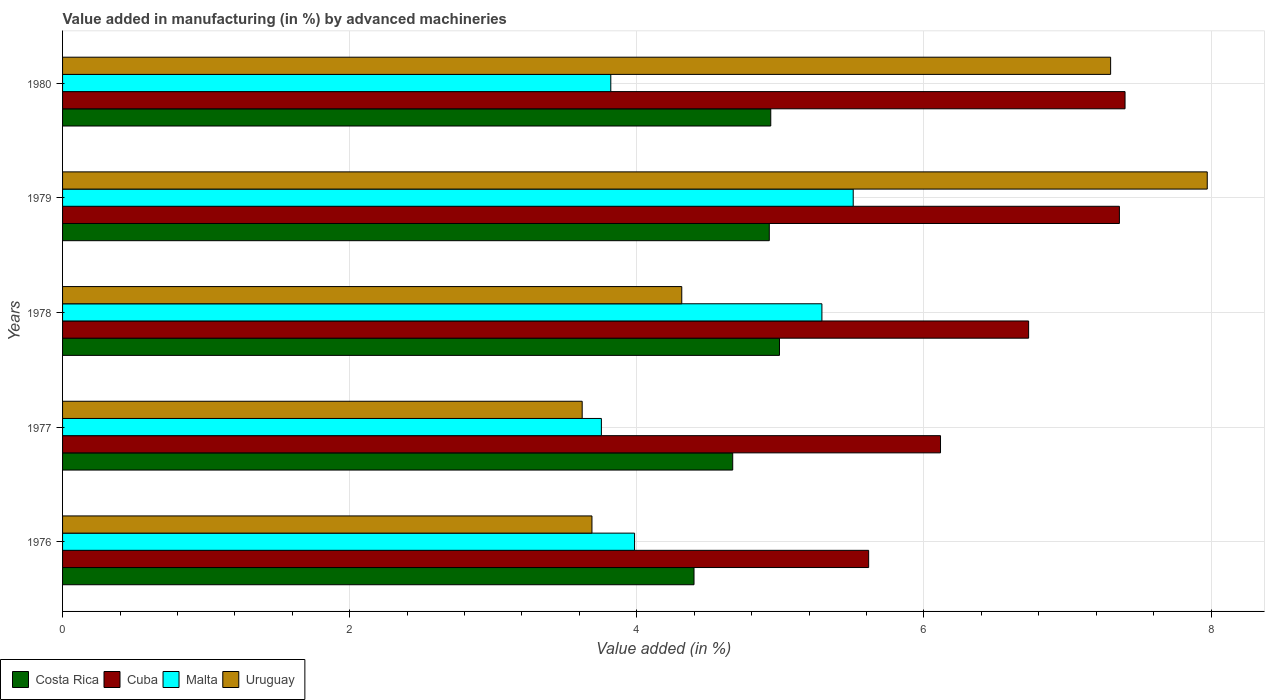How many groups of bars are there?
Make the answer very short. 5. Are the number of bars on each tick of the Y-axis equal?
Your answer should be compact. Yes. How many bars are there on the 5th tick from the top?
Your response must be concise. 4. What is the percentage of value added in manufacturing by advanced machineries in Costa Rica in 1979?
Your answer should be very brief. 4.92. Across all years, what is the maximum percentage of value added in manufacturing by advanced machineries in Malta?
Offer a very short reply. 5.51. Across all years, what is the minimum percentage of value added in manufacturing by advanced machineries in Malta?
Keep it short and to the point. 3.75. In which year was the percentage of value added in manufacturing by advanced machineries in Costa Rica maximum?
Keep it short and to the point. 1978. In which year was the percentage of value added in manufacturing by advanced machineries in Costa Rica minimum?
Keep it short and to the point. 1976. What is the total percentage of value added in manufacturing by advanced machineries in Cuba in the graph?
Provide a succinct answer. 33.22. What is the difference between the percentage of value added in manufacturing by advanced machineries in Costa Rica in 1976 and that in 1980?
Your response must be concise. -0.53. What is the difference between the percentage of value added in manufacturing by advanced machineries in Cuba in 1980 and the percentage of value added in manufacturing by advanced machineries in Costa Rica in 1977?
Your response must be concise. 2.73. What is the average percentage of value added in manufacturing by advanced machineries in Costa Rica per year?
Make the answer very short. 4.78. In the year 1978, what is the difference between the percentage of value added in manufacturing by advanced machineries in Costa Rica and percentage of value added in manufacturing by advanced machineries in Uruguay?
Give a very brief answer. 0.68. In how many years, is the percentage of value added in manufacturing by advanced machineries in Costa Rica greater than 5.6 %?
Offer a very short reply. 0. What is the ratio of the percentage of value added in manufacturing by advanced machineries in Costa Rica in 1977 to that in 1979?
Make the answer very short. 0.95. What is the difference between the highest and the second highest percentage of value added in manufacturing by advanced machineries in Malta?
Your answer should be compact. 0.22. What is the difference between the highest and the lowest percentage of value added in manufacturing by advanced machineries in Uruguay?
Offer a terse response. 4.35. In how many years, is the percentage of value added in manufacturing by advanced machineries in Cuba greater than the average percentage of value added in manufacturing by advanced machineries in Cuba taken over all years?
Offer a very short reply. 3. Is the sum of the percentage of value added in manufacturing by advanced machineries in Cuba in 1978 and 1979 greater than the maximum percentage of value added in manufacturing by advanced machineries in Malta across all years?
Give a very brief answer. Yes. What does the 2nd bar from the top in 1976 represents?
Give a very brief answer. Malta. What does the 3rd bar from the bottom in 1980 represents?
Ensure brevity in your answer.  Malta. Is it the case that in every year, the sum of the percentage of value added in manufacturing by advanced machineries in Costa Rica and percentage of value added in manufacturing by advanced machineries in Uruguay is greater than the percentage of value added in manufacturing by advanced machineries in Cuba?
Keep it short and to the point. Yes. How many years are there in the graph?
Keep it short and to the point. 5. What is the difference between two consecutive major ticks on the X-axis?
Ensure brevity in your answer.  2. Are the values on the major ticks of X-axis written in scientific E-notation?
Your response must be concise. No. Does the graph contain any zero values?
Your answer should be very brief. No. Does the graph contain grids?
Provide a succinct answer. Yes. How many legend labels are there?
Offer a terse response. 4. What is the title of the graph?
Give a very brief answer. Value added in manufacturing (in %) by advanced machineries. Does "United Arab Emirates" appear as one of the legend labels in the graph?
Make the answer very short. No. What is the label or title of the X-axis?
Keep it short and to the point. Value added (in %). What is the Value added (in %) of Costa Rica in 1976?
Keep it short and to the point. 4.4. What is the Value added (in %) in Cuba in 1976?
Your answer should be compact. 5.61. What is the Value added (in %) of Malta in 1976?
Offer a terse response. 3.98. What is the Value added (in %) of Uruguay in 1976?
Make the answer very short. 3.69. What is the Value added (in %) in Costa Rica in 1977?
Your answer should be very brief. 4.67. What is the Value added (in %) in Cuba in 1977?
Your answer should be very brief. 6.12. What is the Value added (in %) in Malta in 1977?
Provide a succinct answer. 3.75. What is the Value added (in %) of Uruguay in 1977?
Offer a terse response. 3.62. What is the Value added (in %) in Costa Rica in 1978?
Provide a short and direct response. 4.99. What is the Value added (in %) in Cuba in 1978?
Offer a terse response. 6.73. What is the Value added (in %) in Malta in 1978?
Offer a terse response. 5.29. What is the Value added (in %) of Uruguay in 1978?
Your answer should be compact. 4.31. What is the Value added (in %) in Costa Rica in 1979?
Your response must be concise. 4.92. What is the Value added (in %) of Cuba in 1979?
Keep it short and to the point. 7.36. What is the Value added (in %) of Malta in 1979?
Offer a terse response. 5.51. What is the Value added (in %) in Uruguay in 1979?
Offer a terse response. 7.97. What is the Value added (in %) of Costa Rica in 1980?
Provide a short and direct response. 4.93. What is the Value added (in %) of Cuba in 1980?
Ensure brevity in your answer.  7.4. What is the Value added (in %) of Malta in 1980?
Provide a short and direct response. 3.82. What is the Value added (in %) of Uruguay in 1980?
Provide a succinct answer. 7.3. Across all years, what is the maximum Value added (in %) of Costa Rica?
Make the answer very short. 4.99. Across all years, what is the maximum Value added (in %) of Cuba?
Keep it short and to the point. 7.4. Across all years, what is the maximum Value added (in %) in Malta?
Provide a succinct answer. 5.51. Across all years, what is the maximum Value added (in %) in Uruguay?
Your answer should be compact. 7.97. Across all years, what is the minimum Value added (in %) in Costa Rica?
Give a very brief answer. 4.4. Across all years, what is the minimum Value added (in %) in Cuba?
Offer a very short reply. 5.61. Across all years, what is the minimum Value added (in %) in Malta?
Keep it short and to the point. 3.75. Across all years, what is the minimum Value added (in %) in Uruguay?
Give a very brief answer. 3.62. What is the total Value added (in %) in Costa Rica in the graph?
Offer a very short reply. 23.91. What is the total Value added (in %) in Cuba in the graph?
Offer a very short reply. 33.22. What is the total Value added (in %) in Malta in the graph?
Provide a succinct answer. 22.35. What is the total Value added (in %) of Uruguay in the graph?
Keep it short and to the point. 26.89. What is the difference between the Value added (in %) of Costa Rica in 1976 and that in 1977?
Provide a succinct answer. -0.27. What is the difference between the Value added (in %) of Cuba in 1976 and that in 1977?
Keep it short and to the point. -0.5. What is the difference between the Value added (in %) in Malta in 1976 and that in 1977?
Offer a terse response. 0.23. What is the difference between the Value added (in %) of Uruguay in 1976 and that in 1977?
Offer a terse response. 0.07. What is the difference between the Value added (in %) in Costa Rica in 1976 and that in 1978?
Provide a succinct answer. -0.6. What is the difference between the Value added (in %) of Cuba in 1976 and that in 1978?
Give a very brief answer. -1.11. What is the difference between the Value added (in %) of Malta in 1976 and that in 1978?
Give a very brief answer. -1.3. What is the difference between the Value added (in %) of Uruguay in 1976 and that in 1978?
Ensure brevity in your answer.  -0.63. What is the difference between the Value added (in %) of Costa Rica in 1976 and that in 1979?
Your response must be concise. -0.52. What is the difference between the Value added (in %) in Cuba in 1976 and that in 1979?
Offer a terse response. -1.75. What is the difference between the Value added (in %) in Malta in 1976 and that in 1979?
Give a very brief answer. -1.52. What is the difference between the Value added (in %) of Uruguay in 1976 and that in 1979?
Provide a short and direct response. -4.29. What is the difference between the Value added (in %) of Costa Rica in 1976 and that in 1980?
Make the answer very short. -0.53. What is the difference between the Value added (in %) of Cuba in 1976 and that in 1980?
Offer a terse response. -1.79. What is the difference between the Value added (in %) in Malta in 1976 and that in 1980?
Your answer should be very brief. 0.17. What is the difference between the Value added (in %) of Uruguay in 1976 and that in 1980?
Offer a terse response. -3.61. What is the difference between the Value added (in %) in Costa Rica in 1977 and that in 1978?
Make the answer very short. -0.33. What is the difference between the Value added (in %) in Cuba in 1977 and that in 1978?
Provide a succinct answer. -0.61. What is the difference between the Value added (in %) in Malta in 1977 and that in 1978?
Give a very brief answer. -1.54. What is the difference between the Value added (in %) of Uruguay in 1977 and that in 1978?
Provide a succinct answer. -0.69. What is the difference between the Value added (in %) in Costa Rica in 1977 and that in 1979?
Provide a short and direct response. -0.25. What is the difference between the Value added (in %) of Cuba in 1977 and that in 1979?
Offer a terse response. -1.25. What is the difference between the Value added (in %) of Malta in 1977 and that in 1979?
Keep it short and to the point. -1.75. What is the difference between the Value added (in %) of Uruguay in 1977 and that in 1979?
Ensure brevity in your answer.  -4.35. What is the difference between the Value added (in %) in Costa Rica in 1977 and that in 1980?
Offer a very short reply. -0.27. What is the difference between the Value added (in %) of Cuba in 1977 and that in 1980?
Keep it short and to the point. -1.29. What is the difference between the Value added (in %) of Malta in 1977 and that in 1980?
Your answer should be very brief. -0.07. What is the difference between the Value added (in %) of Uruguay in 1977 and that in 1980?
Offer a very short reply. -3.68. What is the difference between the Value added (in %) of Costa Rica in 1978 and that in 1979?
Your response must be concise. 0.07. What is the difference between the Value added (in %) in Cuba in 1978 and that in 1979?
Give a very brief answer. -0.63. What is the difference between the Value added (in %) in Malta in 1978 and that in 1979?
Ensure brevity in your answer.  -0.22. What is the difference between the Value added (in %) in Uruguay in 1978 and that in 1979?
Keep it short and to the point. -3.66. What is the difference between the Value added (in %) in Costa Rica in 1978 and that in 1980?
Your response must be concise. 0.06. What is the difference between the Value added (in %) in Cuba in 1978 and that in 1980?
Your answer should be compact. -0.67. What is the difference between the Value added (in %) of Malta in 1978 and that in 1980?
Make the answer very short. 1.47. What is the difference between the Value added (in %) in Uruguay in 1978 and that in 1980?
Give a very brief answer. -2.99. What is the difference between the Value added (in %) in Costa Rica in 1979 and that in 1980?
Your answer should be very brief. -0.01. What is the difference between the Value added (in %) of Cuba in 1979 and that in 1980?
Make the answer very short. -0.04. What is the difference between the Value added (in %) of Malta in 1979 and that in 1980?
Provide a short and direct response. 1.69. What is the difference between the Value added (in %) of Uruguay in 1979 and that in 1980?
Your answer should be very brief. 0.67. What is the difference between the Value added (in %) of Costa Rica in 1976 and the Value added (in %) of Cuba in 1977?
Your answer should be compact. -1.72. What is the difference between the Value added (in %) in Costa Rica in 1976 and the Value added (in %) in Malta in 1977?
Offer a terse response. 0.65. What is the difference between the Value added (in %) of Costa Rica in 1976 and the Value added (in %) of Uruguay in 1977?
Your answer should be compact. 0.78. What is the difference between the Value added (in %) in Cuba in 1976 and the Value added (in %) in Malta in 1977?
Your answer should be compact. 1.86. What is the difference between the Value added (in %) of Cuba in 1976 and the Value added (in %) of Uruguay in 1977?
Keep it short and to the point. 2. What is the difference between the Value added (in %) in Malta in 1976 and the Value added (in %) in Uruguay in 1977?
Provide a succinct answer. 0.36. What is the difference between the Value added (in %) of Costa Rica in 1976 and the Value added (in %) of Cuba in 1978?
Keep it short and to the point. -2.33. What is the difference between the Value added (in %) of Costa Rica in 1976 and the Value added (in %) of Malta in 1978?
Give a very brief answer. -0.89. What is the difference between the Value added (in %) of Costa Rica in 1976 and the Value added (in %) of Uruguay in 1978?
Provide a succinct answer. 0.09. What is the difference between the Value added (in %) of Cuba in 1976 and the Value added (in %) of Malta in 1978?
Provide a succinct answer. 0.33. What is the difference between the Value added (in %) in Cuba in 1976 and the Value added (in %) in Uruguay in 1978?
Ensure brevity in your answer.  1.3. What is the difference between the Value added (in %) of Malta in 1976 and the Value added (in %) of Uruguay in 1978?
Provide a succinct answer. -0.33. What is the difference between the Value added (in %) of Costa Rica in 1976 and the Value added (in %) of Cuba in 1979?
Make the answer very short. -2.96. What is the difference between the Value added (in %) in Costa Rica in 1976 and the Value added (in %) in Malta in 1979?
Your response must be concise. -1.11. What is the difference between the Value added (in %) of Costa Rica in 1976 and the Value added (in %) of Uruguay in 1979?
Your response must be concise. -3.57. What is the difference between the Value added (in %) of Cuba in 1976 and the Value added (in %) of Malta in 1979?
Offer a terse response. 0.11. What is the difference between the Value added (in %) in Cuba in 1976 and the Value added (in %) in Uruguay in 1979?
Provide a short and direct response. -2.36. What is the difference between the Value added (in %) of Malta in 1976 and the Value added (in %) of Uruguay in 1979?
Provide a succinct answer. -3.99. What is the difference between the Value added (in %) of Costa Rica in 1976 and the Value added (in %) of Cuba in 1980?
Your answer should be compact. -3. What is the difference between the Value added (in %) of Costa Rica in 1976 and the Value added (in %) of Malta in 1980?
Your answer should be compact. 0.58. What is the difference between the Value added (in %) of Costa Rica in 1976 and the Value added (in %) of Uruguay in 1980?
Give a very brief answer. -2.9. What is the difference between the Value added (in %) of Cuba in 1976 and the Value added (in %) of Malta in 1980?
Your answer should be very brief. 1.8. What is the difference between the Value added (in %) of Cuba in 1976 and the Value added (in %) of Uruguay in 1980?
Offer a terse response. -1.69. What is the difference between the Value added (in %) in Malta in 1976 and the Value added (in %) in Uruguay in 1980?
Your response must be concise. -3.32. What is the difference between the Value added (in %) of Costa Rica in 1977 and the Value added (in %) of Cuba in 1978?
Provide a short and direct response. -2.06. What is the difference between the Value added (in %) in Costa Rica in 1977 and the Value added (in %) in Malta in 1978?
Your response must be concise. -0.62. What is the difference between the Value added (in %) in Costa Rica in 1977 and the Value added (in %) in Uruguay in 1978?
Provide a short and direct response. 0.35. What is the difference between the Value added (in %) of Cuba in 1977 and the Value added (in %) of Malta in 1978?
Make the answer very short. 0.83. What is the difference between the Value added (in %) in Cuba in 1977 and the Value added (in %) in Uruguay in 1978?
Your answer should be compact. 1.8. What is the difference between the Value added (in %) of Malta in 1977 and the Value added (in %) of Uruguay in 1978?
Your response must be concise. -0.56. What is the difference between the Value added (in %) in Costa Rica in 1977 and the Value added (in %) in Cuba in 1979?
Give a very brief answer. -2.69. What is the difference between the Value added (in %) in Costa Rica in 1977 and the Value added (in %) in Malta in 1979?
Your response must be concise. -0.84. What is the difference between the Value added (in %) in Costa Rica in 1977 and the Value added (in %) in Uruguay in 1979?
Provide a short and direct response. -3.31. What is the difference between the Value added (in %) in Cuba in 1977 and the Value added (in %) in Malta in 1979?
Give a very brief answer. 0.61. What is the difference between the Value added (in %) of Cuba in 1977 and the Value added (in %) of Uruguay in 1979?
Keep it short and to the point. -1.86. What is the difference between the Value added (in %) of Malta in 1977 and the Value added (in %) of Uruguay in 1979?
Ensure brevity in your answer.  -4.22. What is the difference between the Value added (in %) of Costa Rica in 1977 and the Value added (in %) of Cuba in 1980?
Make the answer very short. -2.73. What is the difference between the Value added (in %) of Costa Rica in 1977 and the Value added (in %) of Malta in 1980?
Your response must be concise. 0.85. What is the difference between the Value added (in %) in Costa Rica in 1977 and the Value added (in %) in Uruguay in 1980?
Your answer should be compact. -2.63. What is the difference between the Value added (in %) in Cuba in 1977 and the Value added (in %) in Malta in 1980?
Offer a terse response. 2.3. What is the difference between the Value added (in %) in Cuba in 1977 and the Value added (in %) in Uruguay in 1980?
Your answer should be very brief. -1.18. What is the difference between the Value added (in %) of Malta in 1977 and the Value added (in %) of Uruguay in 1980?
Offer a very short reply. -3.55. What is the difference between the Value added (in %) of Costa Rica in 1978 and the Value added (in %) of Cuba in 1979?
Your response must be concise. -2.37. What is the difference between the Value added (in %) of Costa Rica in 1978 and the Value added (in %) of Malta in 1979?
Provide a short and direct response. -0.51. What is the difference between the Value added (in %) in Costa Rica in 1978 and the Value added (in %) in Uruguay in 1979?
Provide a short and direct response. -2.98. What is the difference between the Value added (in %) of Cuba in 1978 and the Value added (in %) of Malta in 1979?
Provide a short and direct response. 1.22. What is the difference between the Value added (in %) of Cuba in 1978 and the Value added (in %) of Uruguay in 1979?
Make the answer very short. -1.24. What is the difference between the Value added (in %) in Malta in 1978 and the Value added (in %) in Uruguay in 1979?
Provide a succinct answer. -2.68. What is the difference between the Value added (in %) in Costa Rica in 1978 and the Value added (in %) in Cuba in 1980?
Provide a short and direct response. -2.41. What is the difference between the Value added (in %) of Costa Rica in 1978 and the Value added (in %) of Malta in 1980?
Your answer should be very brief. 1.18. What is the difference between the Value added (in %) of Costa Rica in 1978 and the Value added (in %) of Uruguay in 1980?
Your response must be concise. -2.31. What is the difference between the Value added (in %) of Cuba in 1978 and the Value added (in %) of Malta in 1980?
Make the answer very short. 2.91. What is the difference between the Value added (in %) in Cuba in 1978 and the Value added (in %) in Uruguay in 1980?
Offer a terse response. -0.57. What is the difference between the Value added (in %) of Malta in 1978 and the Value added (in %) of Uruguay in 1980?
Keep it short and to the point. -2.01. What is the difference between the Value added (in %) in Costa Rica in 1979 and the Value added (in %) in Cuba in 1980?
Make the answer very short. -2.48. What is the difference between the Value added (in %) in Costa Rica in 1979 and the Value added (in %) in Malta in 1980?
Offer a very short reply. 1.1. What is the difference between the Value added (in %) of Costa Rica in 1979 and the Value added (in %) of Uruguay in 1980?
Provide a short and direct response. -2.38. What is the difference between the Value added (in %) in Cuba in 1979 and the Value added (in %) in Malta in 1980?
Offer a very short reply. 3.54. What is the difference between the Value added (in %) in Cuba in 1979 and the Value added (in %) in Uruguay in 1980?
Your answer should be very brief. 0.06. What is the difference between the Value added (in %) in Malta in 1979 and the Value added (in %) in Uruguay in 1980?
Make the answer very short. -1.79. What is the average Value added (in %) in Costa Rica per year?
Give a very brief answer. 4.78. What is the average Value added (in %) of Cuba per year?
Make the answer very short. 6.64. What is the average Value added (in %) in Malta per year?
Make the answer very short. 4.47. What is the average Value added (in %) of Uruguay per year?
Offer a terse response. 5.38. In the year 1976, what is the difference between the Value added (in %) in Costa Rica and Value added (in %) in Cuba?
Give a very brief answer. -1.22. In the year 1976, what is the difference between the Value added (in %) in Costa Rica and Value added (in %) in Malta?
Keep it short and to the point. 0.41. In the year 1976, what is the difference between the Value added (in %) in Costa Rica and Value added (in %) in Uruguay?
Your answer should be compact. 0.71. In the year 1976, what is the difference between the Value added (in %) in Cuba and Value added (in %) in Malta?
Your answer should be compact. 1.63. In the year 1976, what is the difference between the Value added (in %) in Cuba and Value added (in %) in Uruguay?
Keep it short and to the point. 1.93. In the year 1976, what is the difference between the Value added (in %) of Malta and Value added (in %) of Uruguay?
Offer a very short reply. 0.3. In the year 1977, what is the difference between the Value added (in %) in Costa Rica and Value added (in %) in Cuba?
Give a very brief answer. -1.45. In the year 1977, what is the difference between the Value added (in %) of Costa Rica and Value added (in %) of Malta?
Ensure brevity in your answer.  0.91. In the year 1977, what is the difference between the Value added (in %) in Costa Rica and Value added (in %) in Uruguay?
Keep it short and to the point. 1.05. In the year 1977, what is the difference between the Value added (in %) in Cuba and Value added (in %) in Malta?
Offer a terse response. 2.36. In the year 1977, what is the difference between the Value added (in %) of Cuba and Value added (in %) of Uruguay?
Your answer should be compact. 2.5. In the year 1977, what is the difference between the Value added (in %) of Malta and Value added (in %) of Uruguay?
Give a very brief answer. 0.13. In the year 1978, what is the difference between the Value added (in %) in Costa Rica and Value added (in %) in Cuba?
Your answer should be compact. -1.74. In the year 1978, what is the difference between the Value added (in %) in Costa Rica and Value added (in %) in Malta?
Give a very brief answer. -0.3. In the year 1978, what is the difference between the Value added (in %) in Costa Rica and Value added (in %) in Uruguay?
Give a very brief answer. 0.68. In the year 1978, what is the difference between the Value added (in %) of Cuba and Value added (in %) of Malta?
Make the answer very short. 1.44. In the year 1978, what is the difference between the Value added (in %) of Cuba and Value added (in %) of Uruguay?
Give a very brief answer. 2.42. In the year 1978, what is the difference between the Value added (in %) of Malta and Value added (in %) of Uruguay?
Provide a succinct answer. 0.98. In the year 1979, what is the difference between the Value added (in %) of Costa Rica and Value added (in %) of Cuba?
Give a very brief answer. -2.44. In the year 1979, what is the difference between the Value added (in %) of Costa Rica and Value added (in %) of Malta?
Make the answer very short. -0.58. In the year 1979, what is the difference between the Value added (in %) of Costa Rica and Value added (in %) of Uruguay?
Your answer should be compact. -3.05. In the year 1979, what is the difference between the Value added (in %) of Cuba and Value added (in %) of Malta?
Make the answer very short. 1.85. In the year 1979, what is the difference between the Value added (in %) of Cuba and Value added (in %) of Uruguay?
Ensure brevity in your answer.  -0.61. In the year 1979, what is the difference between the Value added (in %) in Malta and Value added (in %) in Uruguay?
Your answer should be very brief. -2.47. In the year 1980, what is the difference between the Value added (in %) of Costa Rica and Value added (in %) of Cuba?
Your response must be concise. -2.47. In the year 1980, what is the difference between the Value added (in %) of Costa Rica and Value added (in %) of Malta?
Provide a succinct answer. 1.11. In the year 1980, what is the difference between the Value added (in %) in Costa Rica and Value added (in %) in Uruguay?
Offer a very short reply. -2.37. In the year 1980, what is the difference between the Value added (in %) in Cuba and Value added (in %) in Malta?
Offer a very short reply. 3.58. In the year 1980, what is the difference between the Value added (in %) of Cuba and Value added (in %) of Uruguay?
Keep it short and to the point. 0.1. In the year 1980, what is the difference between the Value added (in %) of Malta and Value added (in %) of Uruguay?
Your answer should be very brief. -3.48. What is the ratio of the Value added (in %) of Costa Rica in 1976 to that in 1977?
Provide a short and direct response. 0.94. What is the ratio of the Value added (in %) of Cuba in 1976 to that in 1977?
Make the answer very short. 0.92. What is the ratio of the Value added (in %) of Malta in 1976 to that in 1977?
Give a very brief answer. 1.06. What is the ratio of the Value added (in %) in Uruguay in 1976 to that in 1977?
Provide a succinct answer. 1.02. What is the ratio of the Value added (in %) in Costa Rica in 1976 to that in 1978?
Offer a very short reply. 0.88. What is the ratio of the Value added (in %) in Cuba in 1976 to that in 1978?
Your response must be concise. 0.83. What is the ratio of the Value added (in %) in Malta in 1976 to that in 1978?
Your response must be concise. 0.75. What is the ratio of the Value added (in %) in Uruguay in 1976 to that in 1978?
Keep it short and to the point. 0.85. What is the ratio of the Value added (in %) in Costa Rica in 1976 to that in 1979?
Provide a short and direct response. 0.89. What is the ratio of the Value added (in %) of Cuba in 1976 to that in 1979?
Your response must be concise. 0.76. What is the ratio of the Value added (in %) of Malta in 1976 to that in 1979?
Your response must be concise. 0.72. What is the ratio of the Value added (in %) of Uruguay in 1976 to that in 1979?
Your answer should be very brief. 0.46. What is the ratio of the Value added (in %) of Costa Rica in 1976 to that in 1980?
Provide a short and direct response. 0.89. What is the ratio of the Value added (in %) of Cuba in 1976 to that in 1980?
Provide a succinct answer. 0.76. What is the ratio of the Value added (in %) in Malta in 1976 to that in 1980?
Provide a short and direct response. 1.04. What is the ratio of the Value added (in %) of Uruguay in 1976 to that in 1980?
Offer a terse response. 0.51. What is the ratio of the Value added (in %) in Costa Rica in 1977 to that in 1978?
Ensure brevity in your answer.  0.93. What is the ratio of the Value added (in %) in Cuba in 1977 to that in 1978?
Keep it short and to the point. 0.91. What is the ratio of the Value added (in %) in Malta in 1977 to that in 1978?
Make the answer very short. 0.71. What is the ratio of the Value added (in %) in Uruguay in 1977 to that in 1978?
Keep it short and to the point. 0.84. What is the ratio of the Value added (in %) in Costa Rica in 1977 to that in 1979?
Offer a terse response. 0.95. What is the ratio of the Value added (in %) of Cuba in 1977 to that in 1979?
Ensure brevity in your answer.  0.83. What is the ratio of the Value added (in %) of Malta in 1977 to that in 1979?
Keep it short and to the point. 0.68. What is the ratio of the Value added (in %) of Uruguay in 1977 to that in 1979?
Your response must be concise. 0.45. What is the ratio of the Value added (in %) in Costa Rica in 1977 to that in 1980?
Your answer should be compact. 0.95. What is the ratio of the Value added (in %) of Cuba in 1977 to that in 1980?
Your response must be concise. 0.83. What is the ratio of the Value added (in %) of Malta in 1977 to that in 1980?
Offer a very short reply. 0.98. What is the ratio of the Value added (in %) in Uruguay in 1977 to that in 1980?
Provide a succinct answer. 0.5. What is the ratio of the Value added (in %) in Costa Rica in 1978 to that in 1979?
Your response must be concise. 1.01. What is the ratio of the Value added (in %) of Cuba in 1978 to that in 1979?
Offer a very short reply. 0.91. What is the ratio of the Value added (in %) of Malta in 1978 to that in 1979?
Offer a very short reply. 0.96. What is the ratio of the Value added (in %) of Uruguay in 1978 to that in 1979?
Offer a terse response. 0.54. What is the ratio of the Value added (in %) in Costa Rica in 1978 to that in 1980?
Your answer should be compact. 1.01. What is the ratio of the Value added (in %) of Cuba in 1978 to that in 1980?
Offer a terse response. 0.91. What is the ratio of the Value added (in %) in Malta in 1978 to that in 1980?
Ensure brevity in your answer.  1.39. What is the ratio of the Value added (in %) of Uruguay in 1978 to that in 1980?
Provide a succinct answer. 0.59. What is the ratio of the Value added (in %) in Cuba in 1979 to that in 1980?
Offer a very short reply. 0.99. What is the ratio of the Value added (in %) in Malta in 1979 to that in 1980?
Make the answer very short. 1.44. What is the ratio of the Value added (in %) in Uruguay in 1979 to that in 1980?
Ensure brevity in your answer.  1.09. What is the difference between the highest and the second highest Value added (in %) in Costa Rica?
Your answer should be compact. 0.06. What is the difference between the highest and the second highest Value added (in %) of Cuba?
Offer a very short reply. 0.04. What is the difference between the highest and the second highest Value added (in %) in Malta?
Give a very brief answer. 0.22. What is the difference between the highest and the second highest Value added (in %) of Uruguay?
Your answer should be compact. 0.67. What is the difference between the highest and the lowest Value added (in %) in Costa Rica?
Your answer should be compact. 0.6. What is the difference between the highest and the lowest Value added (in %) of Cuba?
Offer a terse response. 1.79. What is the difference between the highest and the lowest Value added (in %) of Malta?
Make the answer very short. 1.75. What is the difference between the highest and the lowest Value added (in %) of Uruguay?
Your answer should be compact. 4.35. 